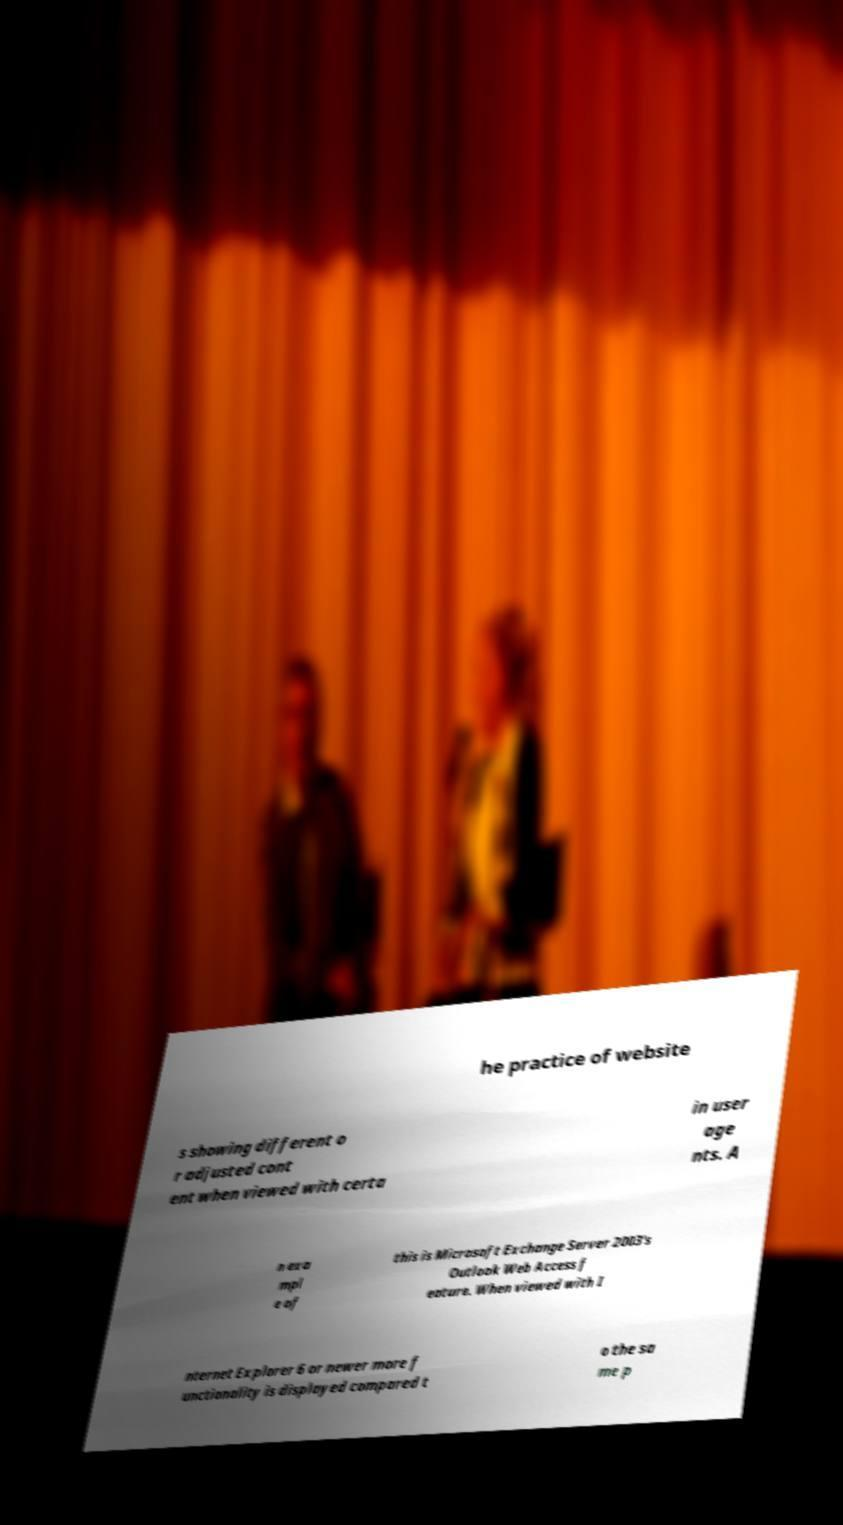Could you assist in decoding the text presented in this image and type it out clearly? he practice of website s showing different o r adjusted cont ent when viewed with certa in user age nts. A n exa mpl e of this is Microsoft Exchange Server 2003's Outlook Web Access f eature. When viewed with I nternet Explorer 6 or newer more f unctionality is displayed compared t o the sa me p 